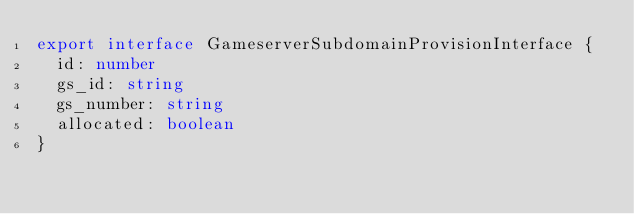<code> <loc_0><loc_0><loc_500><loc_500><_TypeScript_>export interface GameserverSubdomainProvisionInterface {
  id: number
  gs_id: string
  gs_number: string
  allocated: boolean
}
</code> 